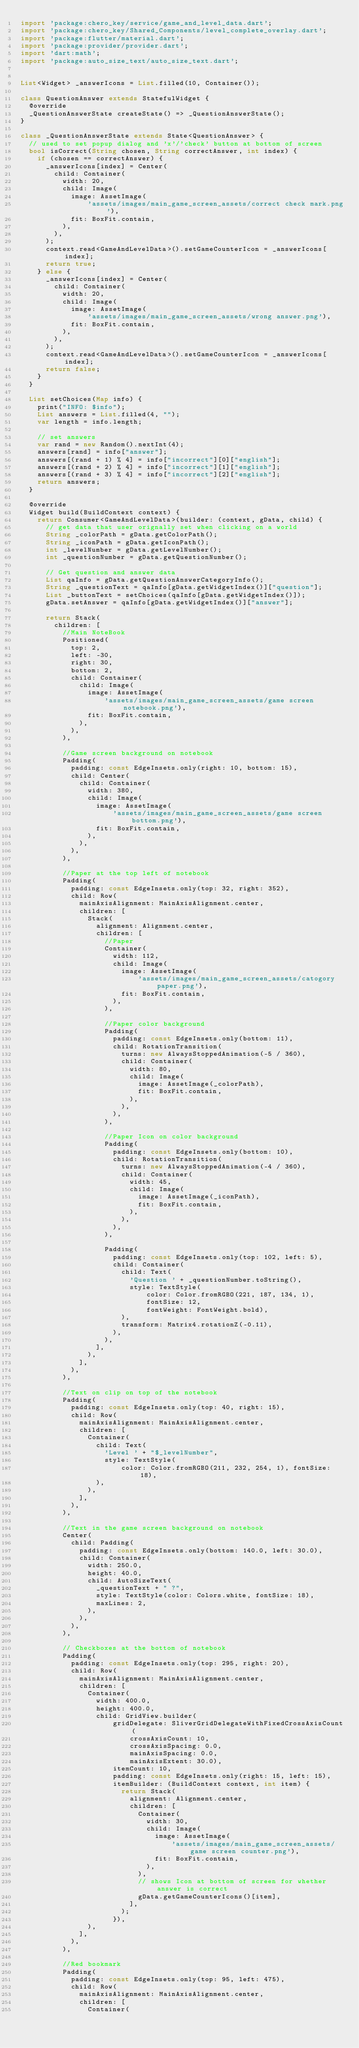<code> <loc_0><loc_0><loc_500><loc_500><_Dart_>import 'package:chero_key/service/game_and_level_data.dart';
import 'package:chero_key/Shared_Components/level_complete_overlay.dart';
import 'package:flutter/material.dart';
import 'package:provider/provider.dart';
import 'dart:math';
import 'package:auto_size_text/auto_size_text.dart';


List<Widget> _answerIcons = List.filled(10, Container());

class QuestionAnswer extends StatefulWidget {
  @override
  _QuestionAnswerState createState() => _QuestionAnswerState();
}

class _QuestionAnswerState extends State<QuestionAnswer> {
  // used to set popup dialog and 'x'/'check' button at bottom of screen
  bool isCorrect(String chosen, String correctAnswer, int index) {
    if (chosen == correctAnswer) {
      _answerIcons[index] = Center(
        child: Container(
          width: 20,
          child: Image(
            image: AssetImage(
                'assets/images/main_game_screen_assets/correct check mark.png'),
            fit: BoxFit.contain,
          ),
        ),
      );
      context.read<GameAndLevelData>().setGameCounterIcon = _answerIcons[index];
      return true;
    } else {
      _answerIcons[index] = Center(
        child: Container(
          width: 20,
          child: Image(
            image: AssetImage(
                'assets/images/main_game_screen_assets/wrong answer.png'),
            fit: BoxFit.contain,
          ),
        ),
      );
      context.read<GameAndLevelData>().setGameCounterIcon = _answerIcons[index];
      return false;
    }
  }

  List setChoices(Map info) {
    print("INFO: $info");
    List answers = List.filled(4, "");
    var length = info.length;

    // set answers
    var rand = new Random().nextInt(4);
    answers[rand] = info["answer"];
    answers[(rand + 1) % 4] = info["incorrect"][0]["english"];
    answers[(rand + 2) % 4] = info["incorrect"][1]["english"];
    answers[(rand + 3) % 4] = info["incorrect"][2]["english"];
    return answers;
  }

  @override
  Widget build(BuildContext context) {
    return Consumer<GameAndLevelData>(builder: (context, gData, child) {
      // get data that user orignally set when clicking on a world
      String _colorPath = gData.getColorPath();
      String _iconPath = gData.getIconPath();
      int _levelNumber = gData.getLevelNumber();
      int _questionNumber = gData.getQuestionNumber();

      // Get question and answer data
      List qaInfo = gData.getQuestionAnswerCategoryInfo();
      String _questionText = qaInfo[gData.getWidgetIndex()]["question"];
      List _buttonText = setChoices(qaInfo[gData.getWidgetIndex()]);
      gData.setAnswer = qaInfo[gData.getWidgetIndex()]["answer"];

      return Stack(
        children: [
          //Main NoteBook
          Positioned(
            top: 2,
            left: -30,
            right: 30,
            bottom: 2,
            child: Container(
              child: Image(
                image: AssetImage(
                    'assets/images/main_game_screen_assets/game screen notebook.png'),
                fit: BoxFit.contain,
              ),
            ),
          ),

          //Game screen background on notebook
          Padding(
            padding: const EdgeInsets.only(right: 10, bottom: 15),
            child: Center(
              child: Container(
                width: 380,
                child: Image(
                  image: AssetImage(
                      'assets/images/main_game_screen_assets/game screen bottom.png'),
                  fit: BoxFit.contain,
                ),
              ),
            ),
          ),

          //Paper at the top left of notebook
          Padding(
            padding: const EdgeInsets.only(top: 32, right: 352),
            child: Row(
              mainAxisAlignment: MainAxisAlignment.center,
              children: [
                Stack(
                  alignment: Alignment.center,
                  children: [
                    //Paper
                    Container(
                      width: 112,
                      child: Image(
                        image: AssetImage(
                            'assets/images/main_game_screen_assets/catogory paper.png'),
                        fit: BoxFit.contain,
                      ),
                    ),

                    //Paper color background
                    Padding(
                      padding: const EdgeInsets.only(bottom: 11),
                      child: RotationTransition(
                        turns: new AlwaysStoppedAnimation(-5 / 360),
                        child: Container(
                          width: 80,
                          child: Image(
                            image: AssetImage(_colorPath),
                            fit: BoxFit.contain,
                          ),
                        ),
                      ),
                    ),

                    //Paper Icon on color background
                    Padding(
                      padding: const EdgeInsets.only(bottom: 10),
                      child: RotationTransition(
                        turns: new AlwaysStoppedAnimation(-4 / 360),
                        child: Container(
                          width: 45,
                          child: Image(
                            image: AssetImage(_iconPath),
                            fit: BoxFit.contain,
                          ),
                        ),
                      ),
                    ),

                    Padding(
                      padding: const EdgeInsets.only(top: 102, left: 5),
                      child: Container(
                        child: Text(
                          'Question ' + _questionNumber.toString(),
                          style: TextStyle(
                              color: Color.fromRGBO(221, 187, 134, 1),
                              fontSize: 12,
                              fontWeight: FontWeight.bold),
                        ),
                        transform: Matrix4.rotationZ(-0.11),
                      ),
                    ),
                  ],
                ),
              ],
            ),
          ),

          //Text on clip on top of the notebook
          Padding(
            padding: const EdgeInsets.only(top: 40, right: 15),
            child: Row(
              mainAxisAlignment: MainAxisAlignment.center,
              children: [
                Container(
                  child: Text(
                    'Level ' + "$_levelNumber",
                    style: TextStyle(
                        color: Color.fromRGBO(211, 232, 254, 1), fontSize: 18),
                  ),
                ),
              ],
            ),
          ),

          //Text in the game screen background on notebook
          Center(
            child: Padding(
              padding: const EdgeInsets.only(bottom: 140.0, left: 30.0),
              child: Container(
                width: 250.0,
                height: 40.0,
                child: AutoSizeText(
                  _questionText + " ?",
                  style: TextStyle(color: Colors.white, fontSize: 18),
                  maxLines: 2,
                ),
              ),
            ),
          ),

          // Checkboxes at the bottom of notebook
          Padding(
            padding: const EdgeInsets.only(top: 295, right: 20),
            child: Row(
              mainAxisAlignment: MainAxisAlignment.center,
              children: [
                Container(
                  width: 400.0,
                  height: 400.0,
                  child: GridView.builder(
                      gridDelegate: SliverGridDelegateWithFixedCrossAxisCount(
                          crossAxisCount: 10,
                          crossAxisSpacing: 0.0,
                          mainAxisSpacing: 0.0,
                          mainAxisExtent: 30.0),
                      itemCount: 10,
                      padding: const EdgeInsets.only(right: 15, left: 15),
                      itemBuilder: (BuildContext context, int item) {
                        return Stack(
                          alignment: Alignment.center,
                          children: [
                            Container(
                              width: 30,
                              child: Image(
                                image: AssetImage(
                                    'assets/images/main_game_screen_assets/game screen counter.png'),
                                fit: BoxFit.contain,
                              ),
                            ),
                            // shows Icon at bottom of screen for whether answer is correct
                            gData.getGameCounterIcons()[item],
                          ],
                        );
                      }),
                ),
              ],
            ),
          ),

          //Red bookmark
          Padding(
            padding: const EdgeInsets.only(top: 95, left: 475),
            child: Row(
              mainAxisAlignment: MainAxisAlignment.center,
              children: [
                Container(</code> 